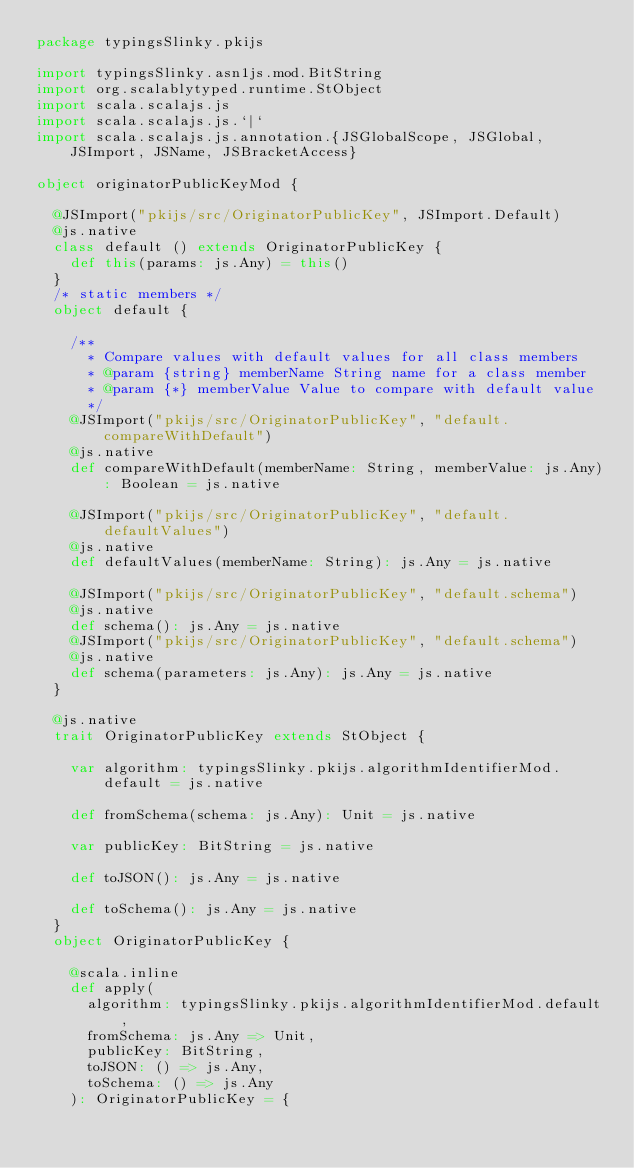<code> <loc_0><loc_0><loc_500><loc_500><_Scala_>package typingsSlinky.pkijs

import typingsSlinky.asn1js.mod.BitString
import org.scalablytyped.runtime.StObject
import scala.scalajs.js
import scala.scalajs.js.`|`
import scala.scalajs.js.annotation.{JSGlobalScope, JSGlobal, JSImport, JSName, JSBracketAccess}

object originatorPublicKeyMod {
  
  @JSImport("pkijs/src/OriginatorPublicKey", JSImport.Default)
  @js.native
  class default () extends OriginatorPublicKey {
    def this(params: js.Any) = this()
  }
  /* static members */
  object default {
    
    /**
      * Compare values with default values for all class members
      * @param {string} memberName String name for a class member
      * @param {*} memberValue Value to compare with default value
      */
    @JSImport("pkijs/src/OriginatorPublicKey", "default.compareWithDefault")
    @js.native
    def compareWithDefault(memberName: String, memberValue: js.Any): Boolean = js.native
    
    @JSImport("pkijs/src/OriginatorPublicKey", "default.defaultValues")
    @js.native
    def defaultValues(memberName: String): js.Any = js.native
    
    @JSImport("pkijs/src/OriginatorPublicKey", "default.schema")
    @js.native
    def schema(): js.Any = js.native
    @JSImport("pkijs/src/OriginatorPublicKey", "default.schema")
    @js.native
    def schema(parameters: js.Any): js.Any = js.native
  }
  
  @js.native
  trait OriginatorPublicKey extends StObject {
    
    var algorithm: typingsSlinky.pkijs.algorithmIdentifierMod.default = js.native
    
    def fromSchema(schema: js.Any): Unit = js.native
    
    var publicKey: BitString = js.native
    
    def toJSON(): js.Any = js.native
    
    def toSchema(): js.Any = js.native
  }
  object OriginatorPublicKey {
    
    @scala.inline
    def apply(
      algorithm: typingsSlinky.pkijs.algorithmIdentifierMod.default,
      fromSchema: js.Any => Unit,
      publicKey: BitString,
      toJSON: () => js.Any,
      toSchema: () => js.Any
    ): OriginatorPublicKey = {</code> 